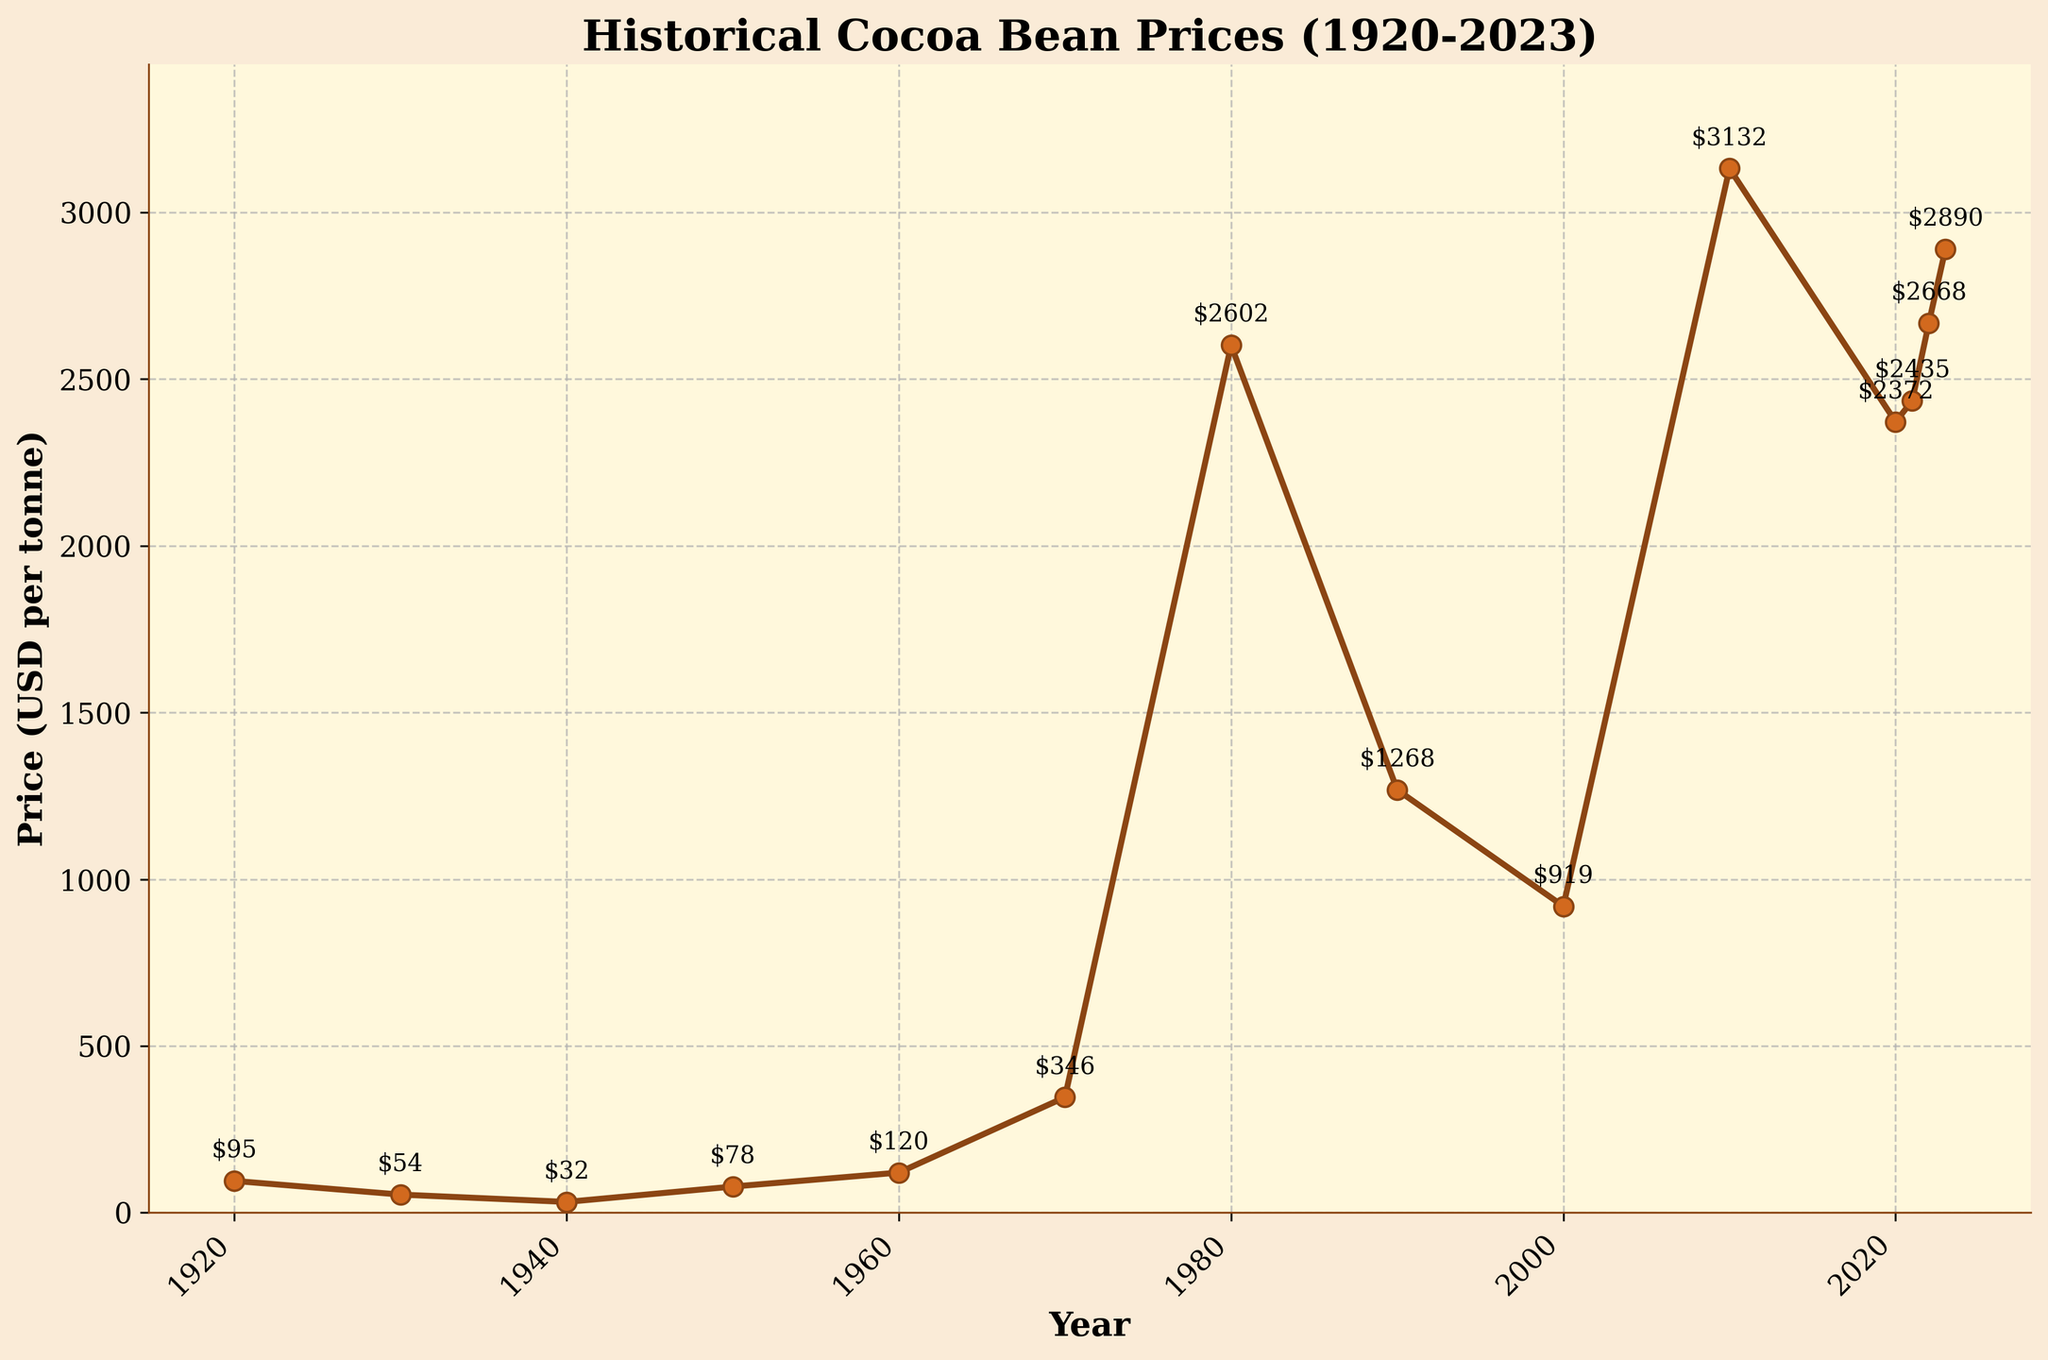What was the price of cocoa beans in 1980? The price in 1980 is directly labeled on the graph. The label reads $2602 per tonne.
Answer: $2602 per tonne Between which years did the price of cocoa beans see the highest increase? To determine the highest increase, we need to identify two adjacent years with the largest difference in prices. The largest increase is from 1970 ($346 per tonne) to 1980 ($2602 per tonne), with a difference of $2256.
Answer: Between 1970 and 1980 What was the average price of cocoa beans from 1920 to 1940? The prices from 1920 to 1940 are $95, $54, and $32. The sum is $181, and there are 3 data points. So, the average price is 181/3.
Answer: $60.33 per tonne How did the price in 2010 compare to the price in 2020? The prices in 2010 and 2020 are labeled on the graph. 2010 was $3132 per tonne, and 2020 was $2372 per tonne. The price in 2010 is higher than in 2020 by $760 per tonne.
Answer: 2010 is higher by $760 per tonne In which decade did the cocoa bean price first exceed $1000 per tonne? The price first exceeds $1000 in the 1980s as the price in 1980 is labeled at $2602 per tonne.
Answer: 1980s What is the trend in cocoa bean prices from 1920 to 2023? The prices show significant fluctuations, starting at a relatively low price of $95 in 1920, peaking multiple times and experiencing a notable spike in 1980 and 2010, showing an overall increasing trend.
Answer: Increasing trend with fluctuations Which year saw a higher price, 1990 or 2000? By comparing the labeled prices on the graph, 1990 has $1268 per tonne, and 2000 has $919 per tonne.
Answer: 1990 What is the range of prices shown in the graph? The range is determined by subtracting the lowest price ($32 in 1940) from the highest price ($3132 in 2010).
Answer: $3100 per tonne What is the median price of cocoa beans from the years given? Ordering the prices: $32, $54, $78, $95, $120, $346, $919, $1268, $2372, $2435, $2602, $2668, $2890, $3132. The median is the 7th value, which is $919.
Answer: $919 per tonne Which year had a significant drop after a peak year? After the peak in 1980 ($2602 per tonne), 1990 sees a drop to $1268 per tonne.
Answer: 1990 